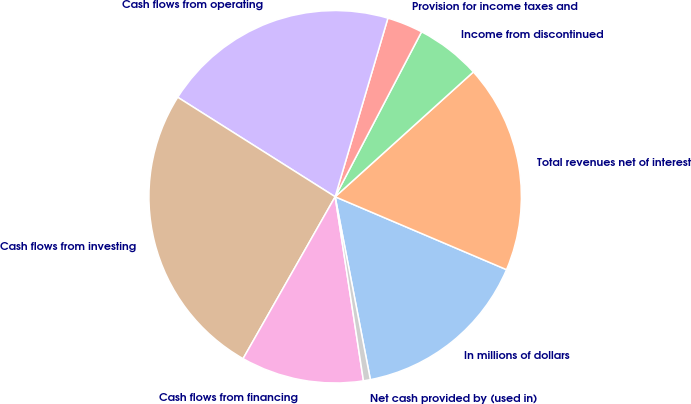Convert chart. <chart><loc_0><loc_0><loc_500><loc_500><pie_chart><fcel>In millions of dollars<fcel>Total revenues net of interest<fcel>Income from discontinued<fcel>Provision for income taxes and<fcel>Cash flows from operating<fcel>Cash flows from investing<fcel>Cash flows from financing<fcel>Net cash provided by (used in)<nl><fcel>15.57%<fcel>18.09%<fcel>5.63%<fcel>3.11%<fcel>20.6%<fcel>25.74%<fcel>10.66%<fcel>0.6%<nl></chart> 